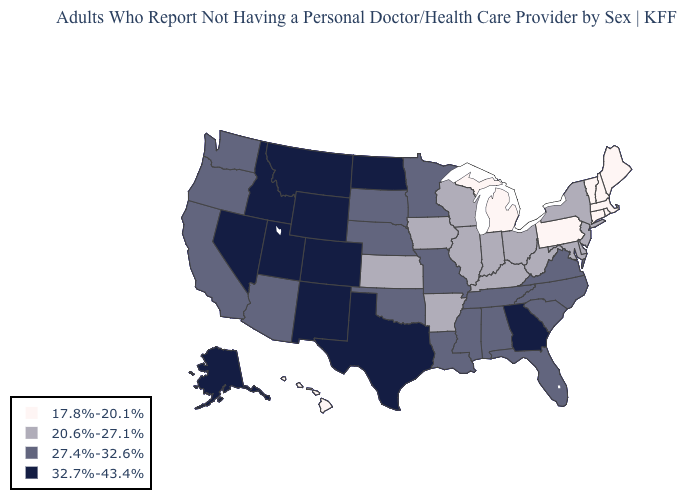Which states have the highest value in the USA?
Short answer required. Alaska, Colorado, Georgia, Idaho, Montana, Nevada, New Mexico, North Dakota, Texas, Utah, Wyoming. Which states have the highest value in the USA?
Short answer required. Alaska, Colorado, Georgia, Idaho, Montana, Nevada, New Mexico, North Dakota, Texas, Utah, Wyoming. Which states hav the highest value in the MidWest?
Write a very short answer. North Dakota. Which states have the highest value in the USA?
Be succinct. Alaska, Colorado, Georgia, Idaho, Montana, Nevada, New Mexico, North Dakota, Texas, Utah, Wyoming. What is the lowest value in the USA?
Give a very brief answer. 17.8%-20.1%. Does Utah have the highest value in the USA?
Concise answer only. Yes. What is the value of Missouri?
Keep it brief. 27.4%-32.6%. Does Pennsylvania have the lowest value in the USA?
Answer briefly. Yes. Name the states that have a value in the range 32.7%-43.4%?
Concise answer only. Alaska, Colorado, Georgia, Idaho, Montana, Nevada, New Mexico, North Dakota, Texas, Utah, Wyoming. Name the states that have a value in the range 27.4%-32.6%?
Quick response, please. Alabama, Arizona, California, Florida, Louisiana, Minnesota, Mississippi, Missouri, Nebraska, North Carolina, Oklahoma, Oregon, South Carolina, South Dakota, Tennessee, Virginia, Washington. Name the states that have a value in the range 32.7%-43.4%?
Write a very short answer. Alaska, Colorado, Georgia, Idaho, Montana, Nevada, New Mexico, North Dakota, Texas, Utah, Wyoming. Name the states that have a value in the range 32.7%-43.4%?
Give a very brief answer. Alaska, Colorado, Georgia, Idaho, Montana, Nevada, New Mexico, North Dakota, Texas, Utah, Wyoming. Which states have the highest value in the USA?
Write a very short answer. Alaska, Colorado, Georgia, Idaho, Montana, Nevada, New Mexico, North Dakota, Texas, Utah, Wyoming. Does Kentucky have a higher value than Pennsylvania?
Write a very short answer. Yes. Does Pennsylvania have a lower value than South Dakota?
Concise answer only. Yes. 